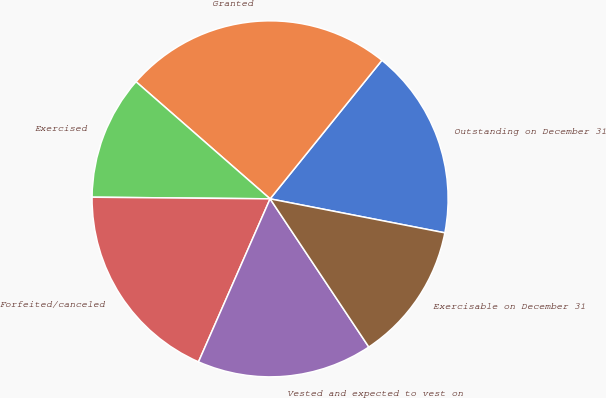Convert chart to OTSL. <chart><loc_0><loc_0><loc_500><loc_500><pie_chart><fcel>Outstanding on December 31<fcel>Granted<fcel>Exercised<fcel>Forfeited/canceled<fcel>Vested and expected to vest on<fcel>Exercisable on December 31<nl><fcel>17.25%<fcel>24.38%<fcel>11.28%<fcel>18.56%<fcel>15.94%<fcel>12.59%<nl></chart> 